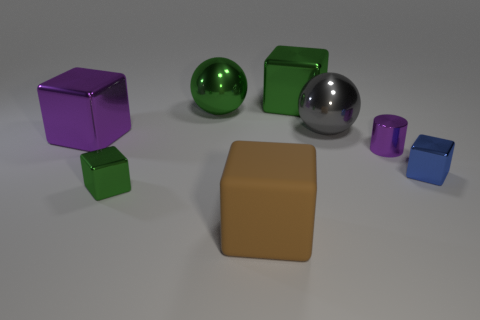How many big metal blocks are both to the right of the rubber block and on the left side of the large rubber object?
Make the answer very short. 0. What size is the blue object that is the same material as the tiny cylinder?
Give a very brief answer. Small. How big is the blue metal block?
Offer a very short reply. Small. What is the material of the tiny green thing?
Provide a short and direct response. Metal. Does the green object that is in front of the blue metallic cube have the same size as the brown rubber thing?
Offer a very short reply. No. How many objects are blocks or large purple blocks?
Keep it short and to the point. 5. There is a shiny object that is the same color as the tiny metal cylinder; what shape is it?
Provide a short and direct response. Cube. There is a thing that is both behind the large matte object and in front of the blue block; what is its size?
Your response must be concise. Small. What number of large gray shiny cylinders are there?
Give a very brief answer. 0. What number of balls are either blue metal objects or big purple objects?
Ensure brevity in your answer.  0. 